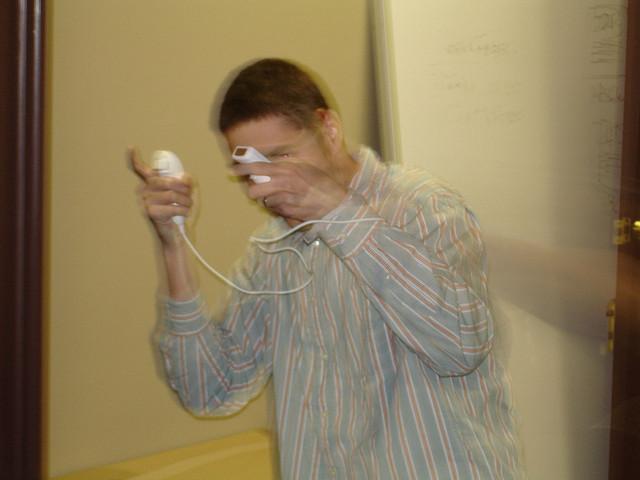How many knives are on the wall?
Give a very brief answer. 0. 